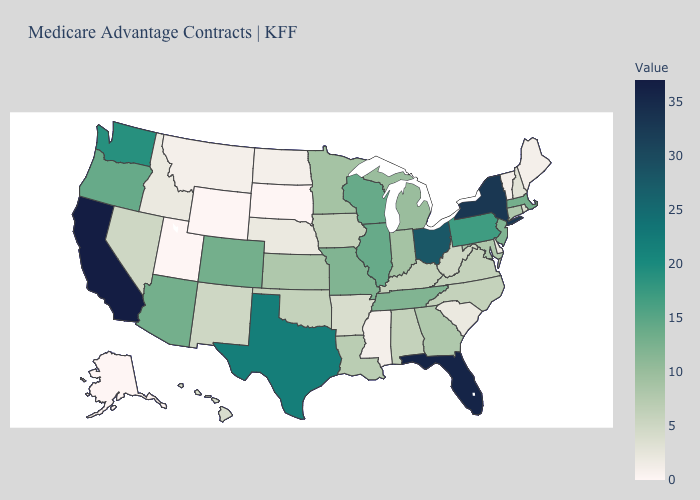Which states have the highest value in the USA?
Write a very short answer. California. Among the states that border Connecticut , does Massachusetts have the highest value?
Short answer required. No. Which states have the highest value in the USA?
Write a very short answer. California. Does Texas have a lower value than Delaware?
Short answer required. No. Which states hav the highest value in the Northeast?
Quick response, please. New York. Does Wyoming have the lowest value in the USA?
Answer briefly. Yes. Does Colorado have the highest value in the West?
Short answer required. No. 